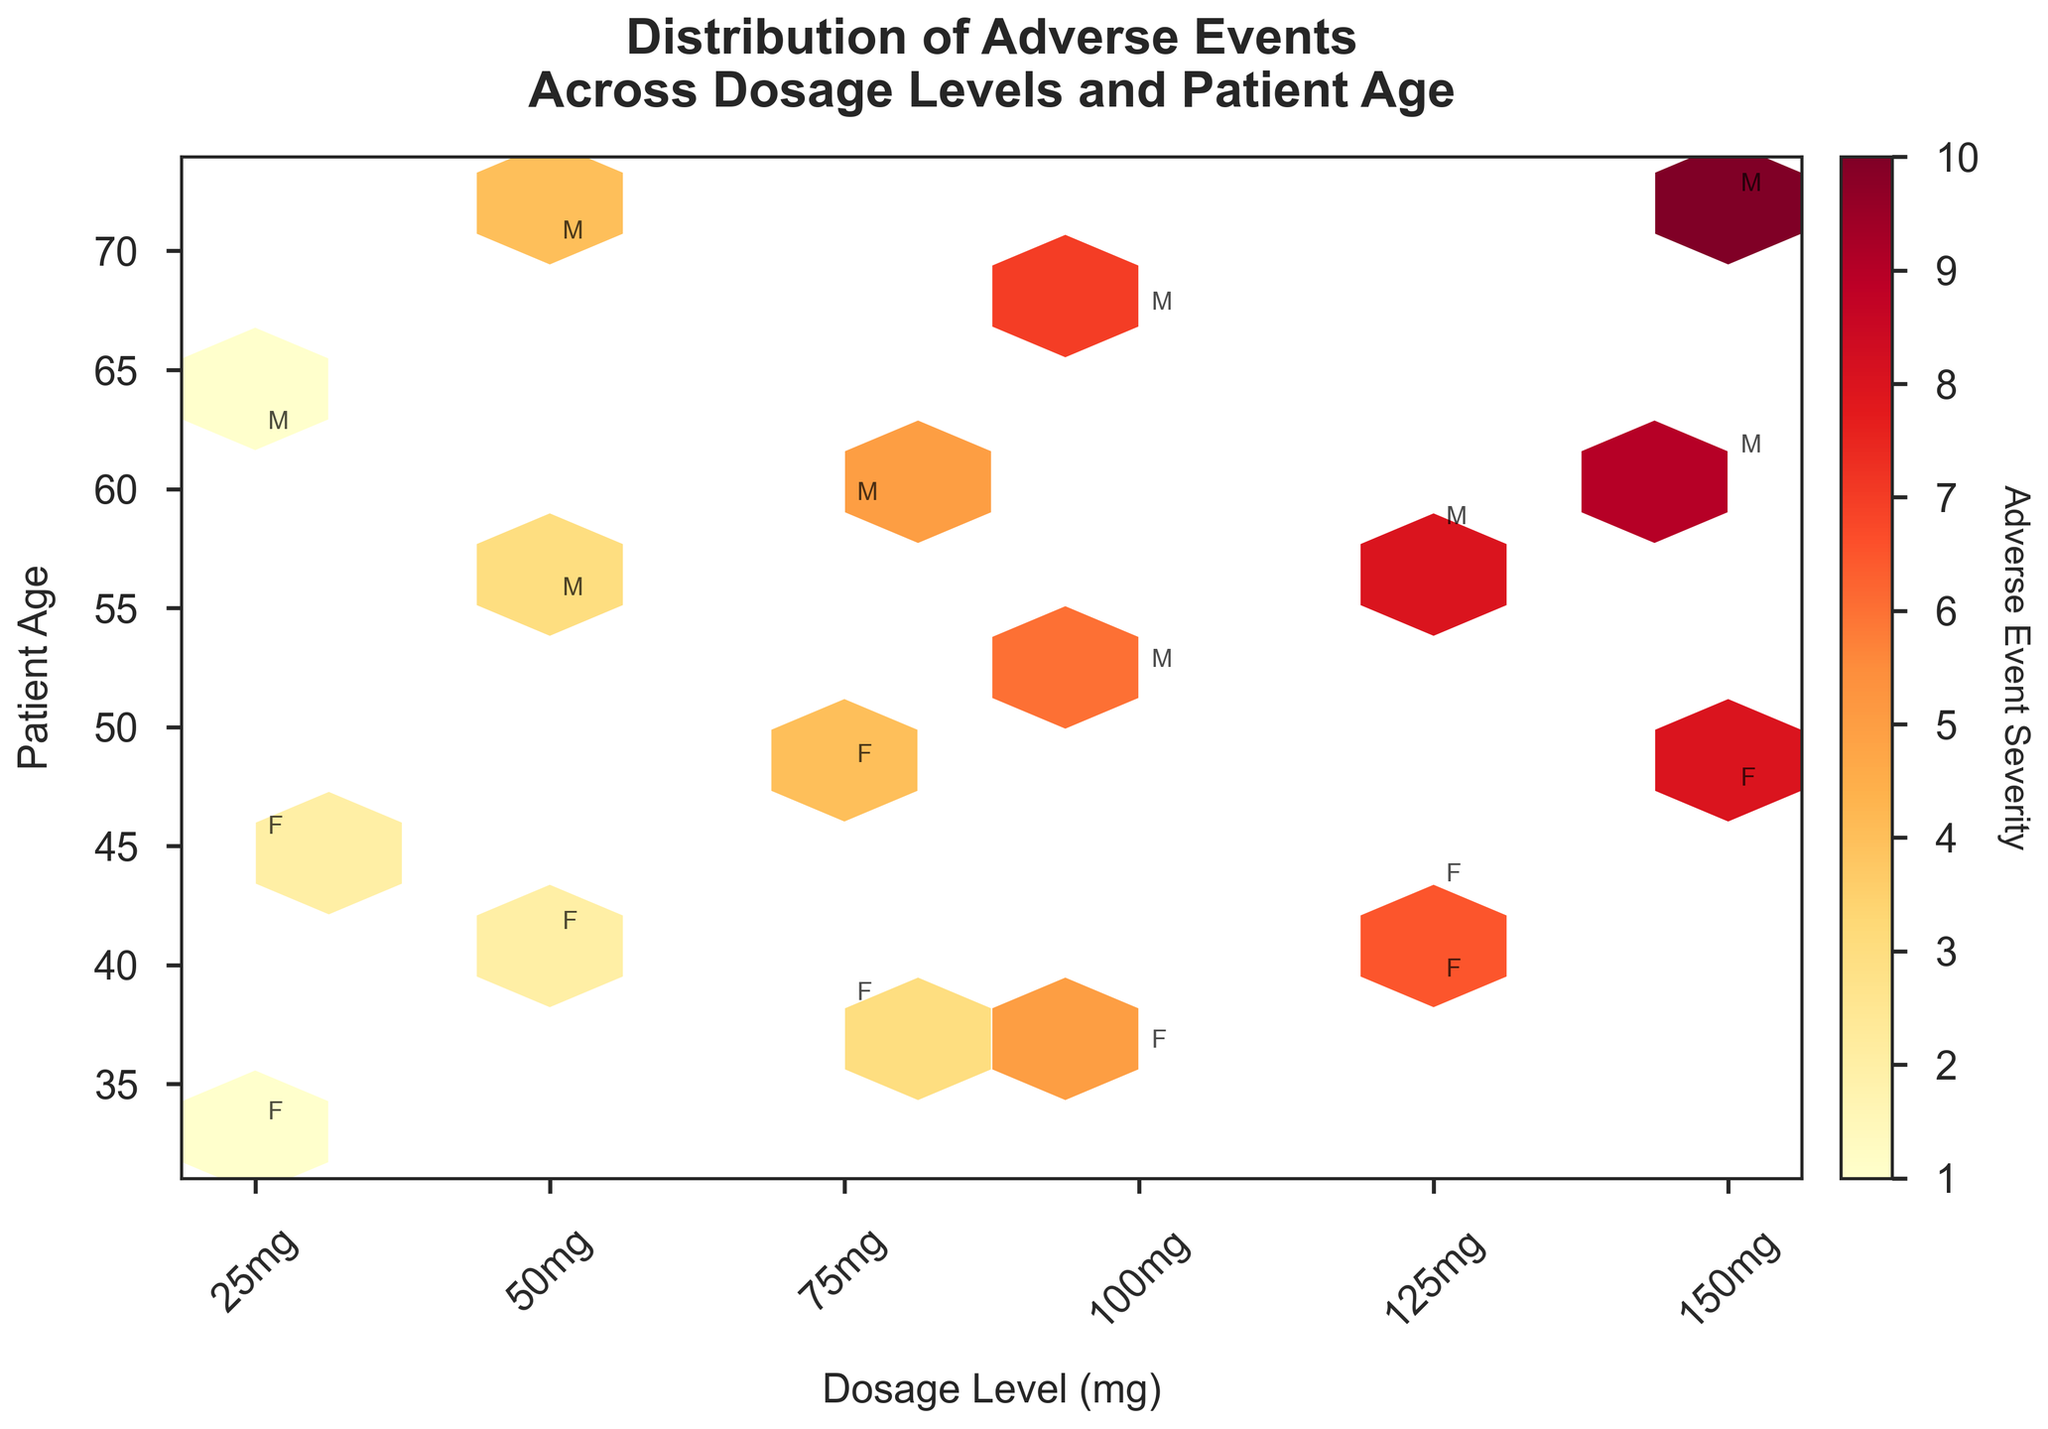Can you identify the title of the plot? The title is usually located at the top of the plot. It provides a brief description of the plot's purpose or the data being visualized. In this instance, the title is "Distribution of Adverse Events Across Dosage Levels and Patient Age."
Answer: Distribution of Adverse Events Across Dosage Levels and Patient Age What is represented on the x-axis? The x-axis shows the range of dosage levels in milligrams, with specific values marked at intervals. Labels such as '25mg', '50mg', '75mg', '100mg', '125mg', and '150mg' can be seen along the axis.
Answer: Dosage Level (mg) What does the color gradient in the hexagons represent? The color gradient in a hexbin plot often indicates the intensity or density of a third variable. Here, the color gradient—from lighter to darker shades of yellow to red—represents the severity of adverse events.
Answer: Adverse Event Severity How is gender denoted on the plot? Gender is annotated by single-letter markers ('M' for male and 'F' for female) placed near the data points within the hexagons. These markers provide additional information about demographic variations.
Answer: By single-letter annotations 'M' and 'F' Which dosage level has the highest occurrence of severe adverse events among older adults? To determine this, locate darker hexagons (indicating more severe adverse events) among the higher age ranges. The darkest hexagons at the highest dosages (150mg) and older ages indicate the most severe adverse events.
Answer: 150mg What is the correlation between dosage levels and patient age in terms of adverse event severity? Examine the hexagons' colors across different dosages and ages. Higher dosages tend to have darker hexagons, especially among older patients, indicating more severe adverse events with increasing dosage levels and age.
Answer: Higher dosages and older ages correlate with greater adverse event severity Are there any dosage levels where young patients tend to experience adverse events with similar severity? Look for similar colors within the hexagons at lower age ranges across the x-axis. Younger patients (ages below 40) at lower dosage levels such as 25mg and 50mg have relatively uniform light colors, indicating similar, lower severities of adverse events.
Answer: Yes, at 25mg Comparing male and female participants, who experienced the most severe adverse events at 100mg dosage? Identify the hexagons at 100mg and check the annotations for gender. Find the darker colored hexagons for male ('M') and female ('F'). Males have more adverse events, as indicated by darker hexagons near their markers.
Answer: Males How does the distribution of adverse events change across dosages for middle-aged patients (ages 40-60)? Assess the hexagons' colors and density between ages 40 to 60 across different dosage levels. Middle-aged patients see increasing adverse event severity with higher dosages, evident by darkening hexagons from 50mg to 150mg.
Answer: Severity increases with dosage What is the most common severity level for adverse events at 75mg in patients aged 30-50? Examine the hexagons at the 75mg level that fall within the age range of 30-50. Determine the predominant color in these hexagons, which generally exhibits darker shades corresponding to higher severity values of 3 and 4.
Answer: 3 and 4 